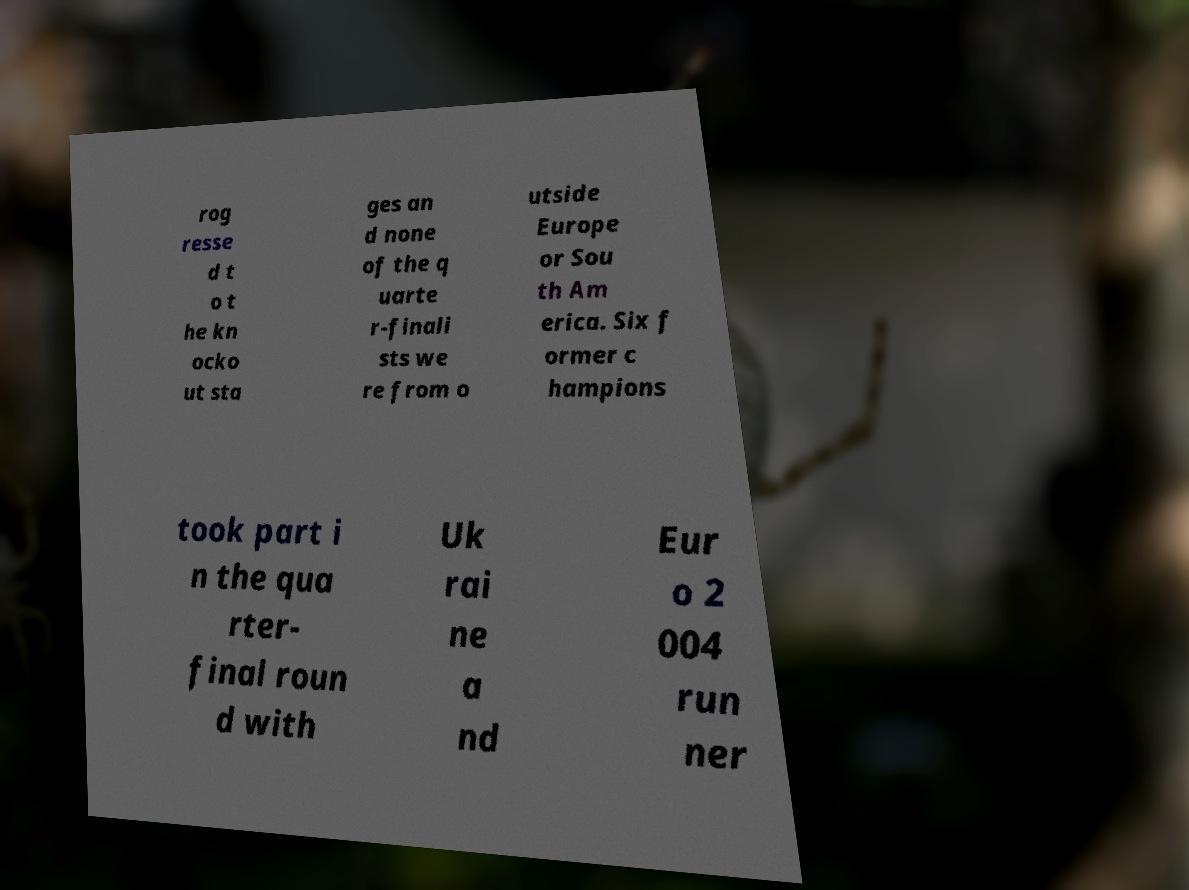Please identify and transcribe the text found in this image. rog resse d t o t he kn ocko ut sta ges an d none of the q uarte r-finali sts we re from o utside Europe or Sou th Am erica. Six f ormer c hampions took part i n the qua rter- final roun d with Uk rai ne a nd Eur o 2 004 run ner 